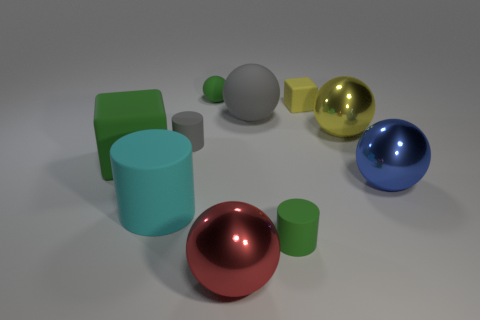Subtract all yellow spheres. How many spheres are left? 4 Subtract all big red balls. How many balls are left? 4 Subtract all purple balls. Subtract all yellow blocks. How many balls are left? 5 Subtract all cylinders. How many objects are left? 7 Subtract 0 cyan cubes. How many objects are left? 10 Subtract all big rubber spheres. Subtract all tiny metal balls. How many objects are left? 9 Add 2 yellow matte things. How many yellow matte things are left? 3 Add 6 yellow metallic objects. How many yellow metallic objects exist? 7 